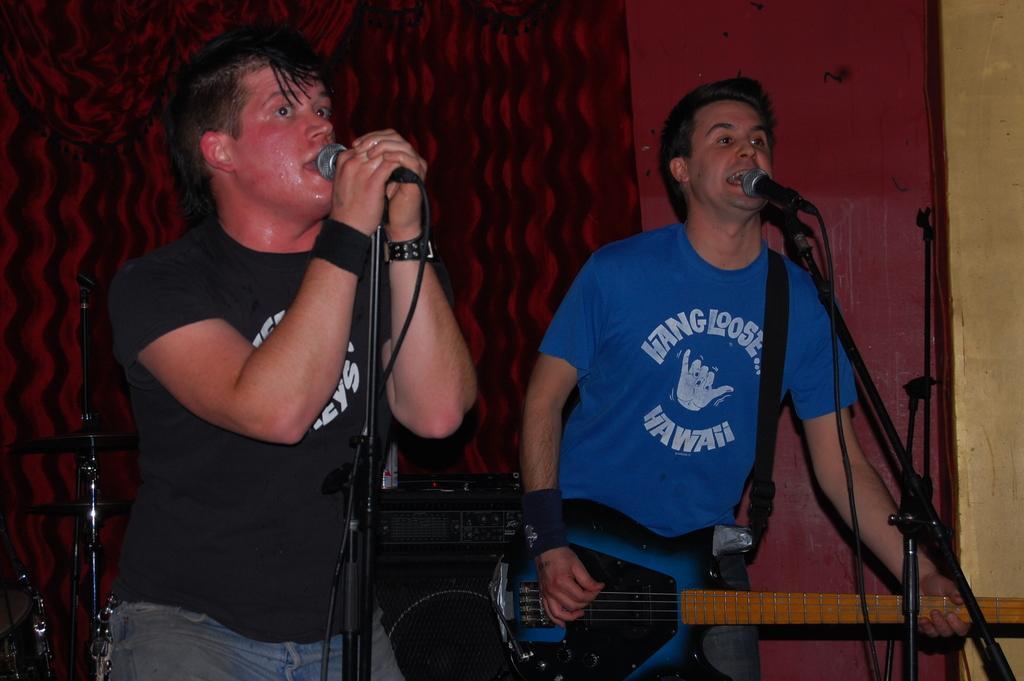Could you give a brief overview of what you see in this image? Front this man wore black t-shirt and singing in-front of mic. Beside this person other man is playing guitar and singing in-front of mic. Backside of this person there is a speaker, above the speaker there is a device. 